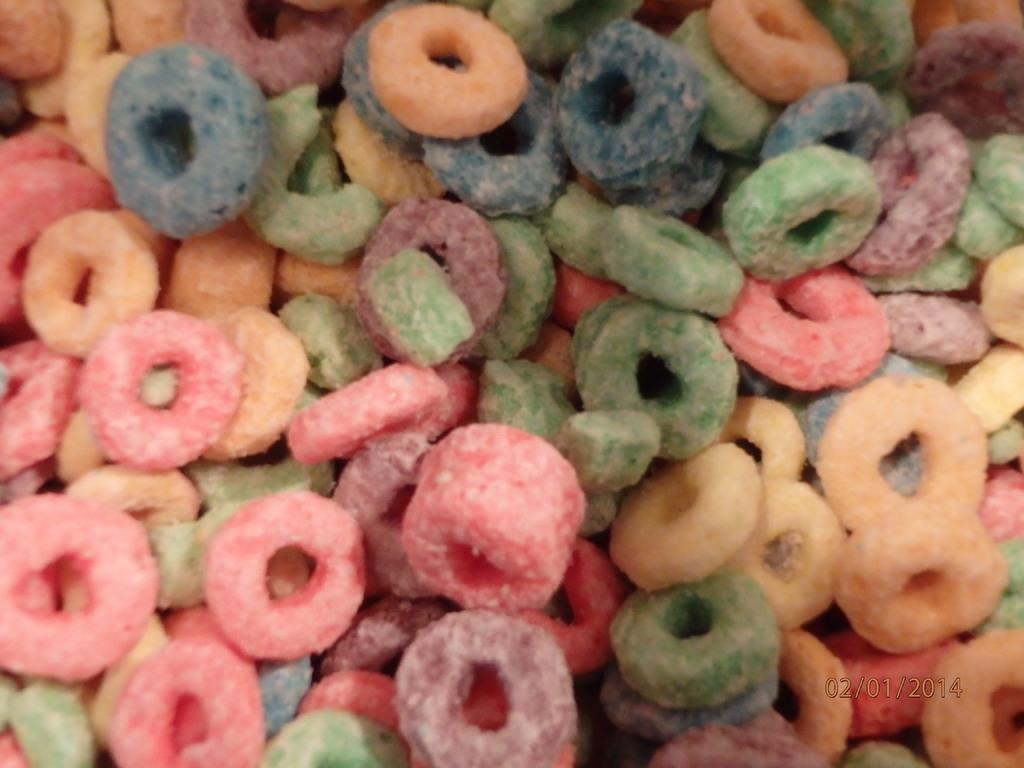What type of food items can be seen in the image? There are colored food items in the image. Can you provide any additional information about the food items? Unfortunately, the provided facts do not offer any further details about the food items. Is there any text visible in the image? Yes, there is a date in the bottom right corner of the image. What type of cannon is being used to rub the food items in the image? There is no cannon present in the image, and the food items are not being rubbed. 